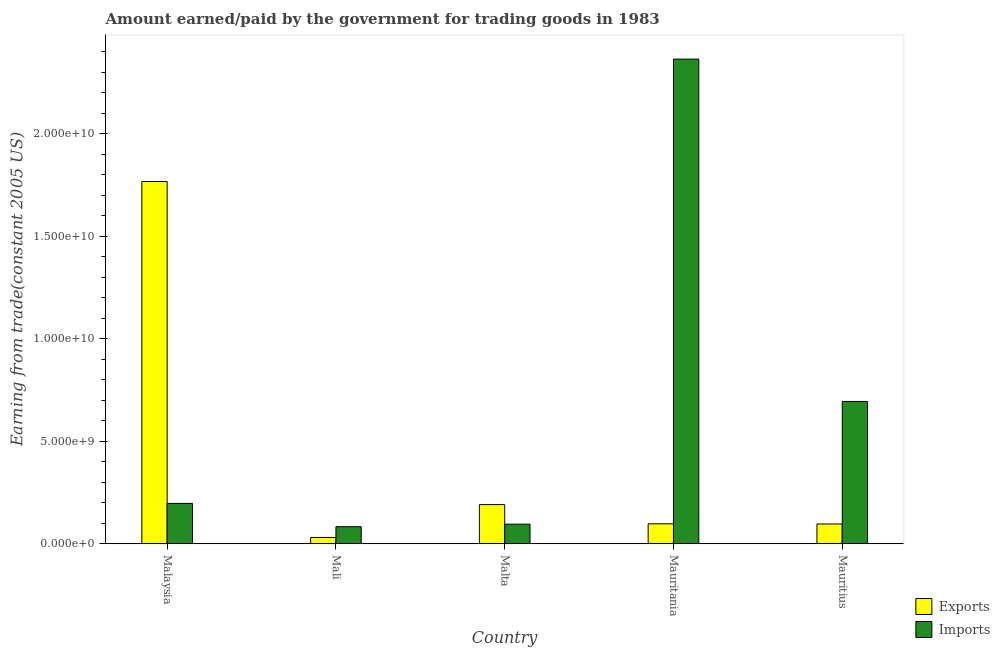Are the number of bars per tick equal to the number of legend labels?
Your response must be concise. Yes. How many bars are there on the 3rd tick from the right?
Give a very brief answer. 2. What is the label of the 4th group of bars from the left?
Offer a very short reply. Mauritania. What is the amount earned from exports in Mauritania?
Offer a very short reply. 9.72e+08. Across all countries, what is the maximum amount paid for imports?
Provide a short and direct response. 2.36e+1. Across all countries, what is the minimum amount paid for imports?
Offer a terse response. 8.32e+08. In which country was the amount paid for imports maximum?
Ensure brevity in your answer.  Mauritania. In which country was the amount paid for imports minimum?
Ensure brevity in your answer.  Mali. What is the total amount paid for imports in the graph?
Offer a terse response. 3.43e+1. What is the difference between the amount paid for imports in Mali and that in Malta?
Provide a succinct answer. -1.23e+08. What is the difference between the amount earned from exports in Mauritania and the amount paid for imports in Mali?
Your response must be concise. 1.40e+08. What is the average amount paid for imports per country?
Make the answer very short. 6.87e+09. What is the difference between the amount paid for imports and amount earned from exports in Mauritius?
Provide a short and direct response. 5.98e+09. In how many countries, is the amount earned from exports greater than 21000000000 US$?
Keep it short and to the point. 0. What is the ratio of the amount paid for imports in Malaysia to that in Mauritania?
Ensure brevity in your answer.  0.08. Is the amount paid for imports in Malaysia less than that in Mali?
Provide a succinct answer. No. What is the difference between the highest and the second highest amount paid for imports?
Your answer should be very brief. 1.67e+1. What is the difference between the highest and the lowest amount paid for imports?
Your answer should be very brief. 2.28e+1. In how many countries, is the amount paid for imports greater than the average amount paid for imports taken over all countries?
Ensure brevity in your answer.  2. What does the 1st bar from the left in Mali represents?
Offer a very short reply. Exports. What does the 1st bar from the right in Malaysia represents?
Give a very brief answer. Imports. How many bars are there?
Offer a very short reply. 10. How many countries are there in the graph?
Offer a very short reply. 5. What is the difference between two consecutive major ticks on the Y-axis?
Ensure brevity in your answer.  5.00e+09. Does the graph contain grids?
Ensure brevity in your answer.  No. Where does the legend appear in the graph?
Provide a short and direct response. Bottom right. What is the title of the graph?
Your answer should be very brief. Amount earned/paid by the government for trading goods in 1983. What is the label or title of the Y-axis?
Make the answer very short. Earning from trade(constant 2005 US). What is the Earning from trade(constant 2005 US) in Exports in Malaysia?
Your answer should be compact. 1.77e+1. What is the Earning from trade(constant 2005 US) in Imports in Malaysia?
Offer a very short reply. 1.97e+09. What is the Earning from trade(constant 2005 US) of Exports in Mali?
Give a very brief answer. 3.08e+08. What is the Earning from trade(constant 2005 US) of Imports in Mali?
Your answer should be very brief. 8.32e+08. What is the Earning from trade(constant 2005 US) in Exports in Malta?
Provide a succinct answer. 1.91e+09. What is the Earning from trade(constant 2005 US) of Imports in Malta?
Make the answer very short. 9.55e+08. What is the Earning from trade(constant 2005 US) in Exports in Mauritania?
Ensure brevity in your answer.  9.72e+08. What is the Earning from trade(constant 2005 US) in Imports in Mauritania?
Offer a terse response. 2.36e+1. What is the Earning from trade(constant 2005 US) in Exports in Mauritius?
Ensure brevity in your answer.  9.65e+08. What is the Earning from trade(constant 2005 US) of Imports in Mauritius?
Provide a succinct answer. 6.94e+09. Across all countries, what is the maximum Earning from trade(constant 2005 US) in Exports?
Offer a very short reply. 1.77e+1. Across all countries, what is the maximum Earning from trade(constant 2005 US) of Imports?
Offer a terse response. 2.36e+1. Across all countries, what is the minimum Earning from trade(constant 2005 US) in Exports?
Make the answer very short. 3.08e+08. Across all countries, what is the minimum Earning from trade(constant 2005 US) in Imports?
Your answer should be compact. 8.32e+08. What is the total Earning from trade(constant 2005 US) of Exports in the graph?
Give a very brief answer. 2.18e+1. What is the total Earning from trade(constant 2005 US) in Imports in the graph?
Offer a terse response. 3.43e+1. What is the difference between the Earning from trade(constant 2005 US) of Exports in Malaysia and that in Mali?
Your response must be concise. 1.74e+1. What is the difference between the Earning from trade(constant 2005 US) of Imports in Malaysia and that in Mali?
Make the answer very short. 1.14e+09. What is the difference between the Earning from trade(constant 2005 US) in Exports in Malaysia and that in Malta?
Your response must be concise. 1.58e+1. What is the difference between the Earning from trade(constant 2005 US) in Imports in Malaysia and that in Malta?
Offer a terse response. 1.01e+09. What is the difference between the Earning from trade(constant 2005 US) in Exports in Malaysia and that in Mauritania?
Ensure brevity in your answer.  1.67e+1. What is the difference between the Earning from trade(constant 2005 US) of Imports in Malaysia and that in Mauritania?
Your answer should be very brief. -2.17e+1. What is the difference between the Earning from trade(constant 2005 US) in Exports in Malaysia and that in Mauritius?
Your answer should be very brief. 1.67e+1. What is the difference between the Earning from trade(constant 2005 US) in Imports in Malaysia and that in Mauritius?
Ensure brevity in your answer.  -4.97e+09. What is the difference between the Earning from trade(constant 2005 US) in Exports in Mali and that in Malta?
Ensure brevity in your answer.  -1.60e+09. What is the difference between the Earning from trade(constant 2005 US) of Imports in Mali and that in Malta?
Offer a very short reply. -1.23e+08. What is the difference between the Earning from trade(constant 2005 US) in Exports in Mali and that in Mauritania?
Ensure brevity in your answer.  -6.64e+08. What is the difference between the Earning from trade(constant 2005 US) of Imports in Mali and that in Mauritania?
Offer a terse response. -2.28e+1. What is the difference between the Earning from trade(constant 2005 US) in Exports in Mali and that in Mauritius?
Offer a terse response. -6.58e+08. What is the difference between the Earning from trade(constant 2005 US) of Imports in Mali and that in Mauritius?
Keep it short and to the point. -6.11e+09. What is the difference between the Earning from trade(constant 2005 US) in Exports in Malta and that in Mauritania?
Make the answer very short. 9.38e+08. What is the difference between the Earning from trade(constant 2005 US) of Imports in Malta and that in Mauritania?
Provide a succinct answer. -2.27e+1. What is the difference between the Earning from trade(constant 2005 US) of Exports in Malta and that in Mauritius?
Offer a terse response. 9.45e+08. What is the difference between the Earning from trade(constant 2005 US) of Imports in Malta and that in Mauritius?
Your response must be concise. -5.99e+09. What is the difference between the Earning from trade(constant 2005 US) in Exports in Mauritania and that in Mauritius?
Offer a terse response. 6.75e+06. What is the difference between the Earning from trade(constant 2005 US) in Imports in Mauritania and that in Mauritius?
Offer a terse response. 1.67e+1. What is the difference between the Earning from trade(constant 2005 US) in Exports in Malaysia and the Earning from trade(constant 2005 US) in Imports in Mali?
Ensure brevity in your answer.  1.68e+1. What is the difference between the Earning from trade(constant 2005 US) of Exports in Malaysia and the Earning from trade(constant 2005 US) of Imports in Malta?
Provide a succinct answer. 1.67e+1. What is the difference between the Earning from trade(constant 2005 US) of Exports in Malaysia and the Earning from trade(constant 2005 US) of Imports in Mauritania?
Offer a very short reply. -5.97e+09. What is the difference between the Earning from trade(constant 2005 US) in Exports in Malaysia and the Earning from trade(constant 2005 US) in Imports in Mauritius?
Give a very brief answer. 1.07e+1. What is the difference between the Earning from trade(constant 2005 US) in Exports in Mali and the Earning from trade(constant 2005 US) in Imports in Malta?
Give a very brief answer. -6.47e+08. What is the difference between the Earning from trade(constant 2005 US) of Exports in Mali and the Earning from trade(constant 2005 US) of Imports in Mauritania?
Offer a very short reply. -2.33e+1. What is the difference between the Earning from trade(constant 2005 US) in Exports in Mali and the Earning from trade(constant 2005 US) in Imports in Mauritius?
Your response must be concise. -6.63e+09. What is the difference between the Earning from trade(constant 2005 US) of Exports in Malta and the Earning from trade(constant 2005 US) of Imports in Mauritania?
Your answer should be very brief. -2.17e+1. What is the difference between the Earning from trade(constant 2005 US) in Exports in Malta and the Earning from trade(constant 2005 US) in Imports in Mauritius?
Keep it short and to the point. -5.03e+09. What is the difference between the Earning from trade(constant 2005 US) of Exports in Mauritania and the Earning from trade(constant 2005 US) of Imports in Mauritius?
Give a very brief answer. -5.97e+09. What is the average Earning from trade(constant 2005 US) in Exports per country?
Your answer should be very brief. 4.37e+09. What is the average Earning from trade(constant 2005 US) in Imports per country?
Ensure brevity in your answer.  6.87e+09. What is the difference between the Earning from trade(constant 2005 US) in Exports and Earning from trade(constant 2005 US) in Imports in Malaysia?
Offer a very short reply. 1.57e+1. What is the difference between the Earning from trade(constant 2005 US) of Exports and Earning from trade(constant 2005 US) of Imports in Mali?
Provide a succinct answer. -5.24e+08. What is the difference between the Earning from trade(constant 2005 US) in Exports and Earning from trade(constant 2005 US) in Imports in Malta?
Your answer should be compact. 9.55e+08. What is the difference between the Earning from trade(constant 2005 US) in Exports and Earning from trade(constant 2005 US) in Imports in Mauritania?
Offer a very short reply. -2.27e+1. What is the difference between the Earning from trade(constant 2005 US) of Exports and Earning from trade(constant 2005 US) of Imports in Mauritius?
Keep it short and to the point. -5.98e+09. What is the ratio of the Earning from trade(constant 2005 US) of Exports in Malaysia to that in Mali?
Give a very brief answer. 57.46. What is the ratio of the Earning from trade(constant 2005 US) of Imports in Malaysia to that in Mali?
Provide a succinct answer. 2.37. What is the ratio of the Earning from trade(constant 2005 US) in Exports in Malaysia to that in Malta?
Offer a very short reply. 9.25. What is the ratio of the Earning from trade(constant 2005 US) of Imports in Malaysia to that in Malta?
Your answer should be very brief. 2.06. What is the ratio of the Earning from trade(constant 2005 US) in Exports in Malaysia to that in Mauritania?
Provide a succinct answer. 18.18. What is the ratio of the Earning from trade(constant 2005 US) in Imports in Malaysia to that in Mauritania?
Offer a very short reply. 0.08. What is the ratio of the Earning from trade(constant 2005 US) of Exports in Malaysia to that in Mauritius?
Provide a succinct answer. 18.31. What is the ratio of the Earning from trade(constant 2005 US) of Imports in Malaysia to that in Mauritius?
Your answer should be compact. 0.28. What is the ratio of the Earning from trade(constant 2005 US) of Exports in Mali to that in Malta?
Provide a succinct answer. 0.16. What is the ratio of the Earning from trade(constant 2005 US) in Imports in Mali to that in Malta?
Ensure brevity in your answer.  0.87. What is the ratio of the Earning from trade(constant 2005 US) of Exports in Mali to that in Mauritania?
Your answer should be very brief. 0.32. What is the ratio of the Earning from trade(constant 2005 US) of Imports in Mali to that in Mauritania?
Provide a short and direct response. 0.04. What is the ratio of the Earning from trade(constant 2005 US) in Exports in Mali to that in Mauritius?
Ensure brevity in your answer.  0.32. What is the ratio of the Earning from trade(constant 2005 US) in Imports in Mali to that in Mauritius?
Offer a terse response. 0.12. What is the ratio of the Earning from trade(constant 2005 US) of Exports in Malta to that in Mauritania?
Keep it short and to the point. 1.97. What is the ratio of the Earning from trade(constant 2005 US) of Imports in Malta to that in Mauritania?
Ensure brevity in your answer.  0.04. What is the ratio of the Earning from trade(constant 2005 US) of Exports in Malta to that in Mauritius?
Provide a short and direct response. 1.98. What is the ratio of the Earning from trade(constant 2005 US) in Imports in Malta to that in Mauritius?
Your answer should be compact. 0.14. What is the ratio of the Earning from trade(constant 2005 US) of Imports in Mauritania to that in Mauritius?
Offer a terse response. 3.41. What is the difference between the highest and the second highest Earning from trade(constant 2005 US) in Exports?
Offer a terse response. 1.58e+1. What is the difference between the highest and the second highest Earning from trade(constant 2005 US) of Imports?
Your response must be concise. 1.67e+1. What is the difference between the highest and the lowest Earning from trade(constant 2005 US) of Exports?
Your response must be concise. 1.74e+1. What is the difference between the highest and the lowest Earning from trade(constant 2005 US) of Imports?
Your answer should be compact. 2.28e+1. 